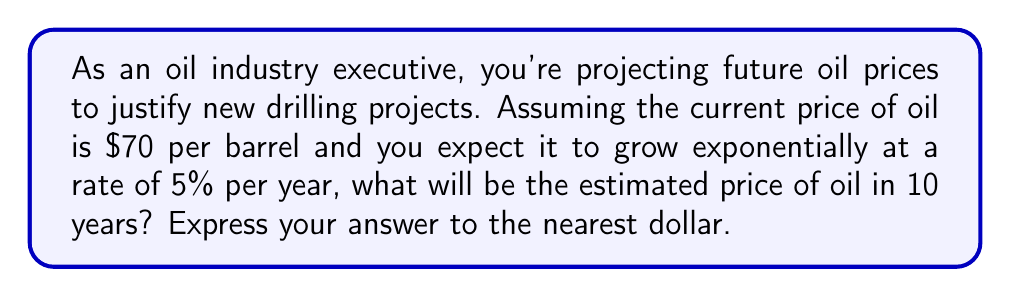Provide a solution to this math problem. Let's approach this step-by-step using an exponential function:

1) The general form of an exponential growth function is:
   $$ A(t) = A_0 \cdot (1 + r)^t $$
   Where:
   $A(t)$ is the amount after time $t$
   $A_0$ is the initial amount
   $r$ is the growth rate (as a decimal)
   $t$ is the time period

2) In this case:
   $A_0 = 70$ (initial price of oil)
   $r = 0.05$ (5% growth rate)
   $t = 10$ (years)

3) Plugging these values into our equation:
   $$ A(10) = 70 \cdot (1 + 0.05)^{10} $$

4) Simplify:
   $$ A(10) = 70 \cdot (1.05)^{10} $$

5) Calculate:
   $$ A(10) = 70 \cdot 1.6288946... $$
   $$ A(10) = 114.02262... $$

6) Rounding to the nearest dollar:
   $$ A(10) \approx 114 $$
Answer: $114 